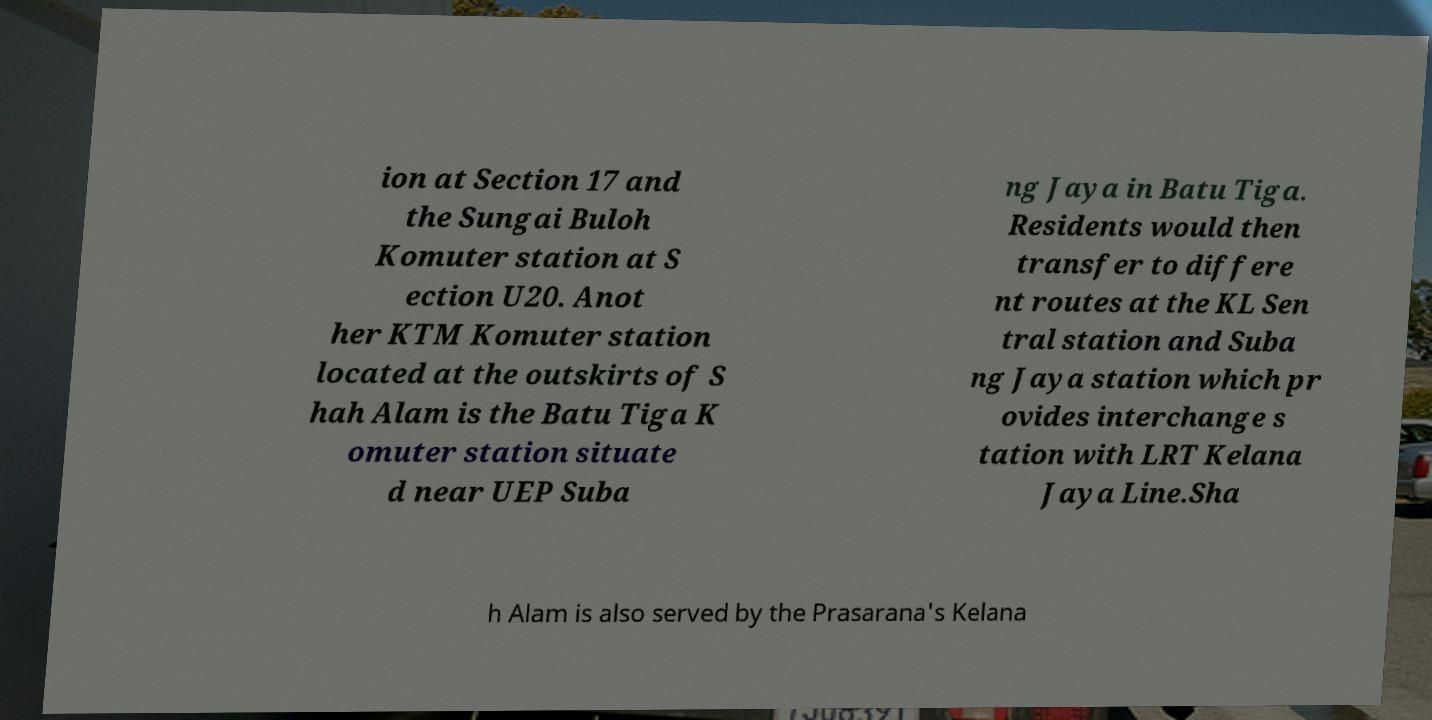Could you assist in decoding the text presented in this image and type it out clearly? ion at Section 17 and the Sungai Buloh Komuter station at S ection U20. Anot her KTM Komuter station located at the outskirts of S hah Alam is the Batu Tiga K omuter station situate d near UEP Suba ng Jaya in Batu Tiga. Residents would then transfer to differe nt routes at the KL Sen tral station and Suba ng Jaya station which pr ovides interchange s tation with LRT Kelana Jaya Line.Sha h Alam is also served by the Prasarana's Kelana 